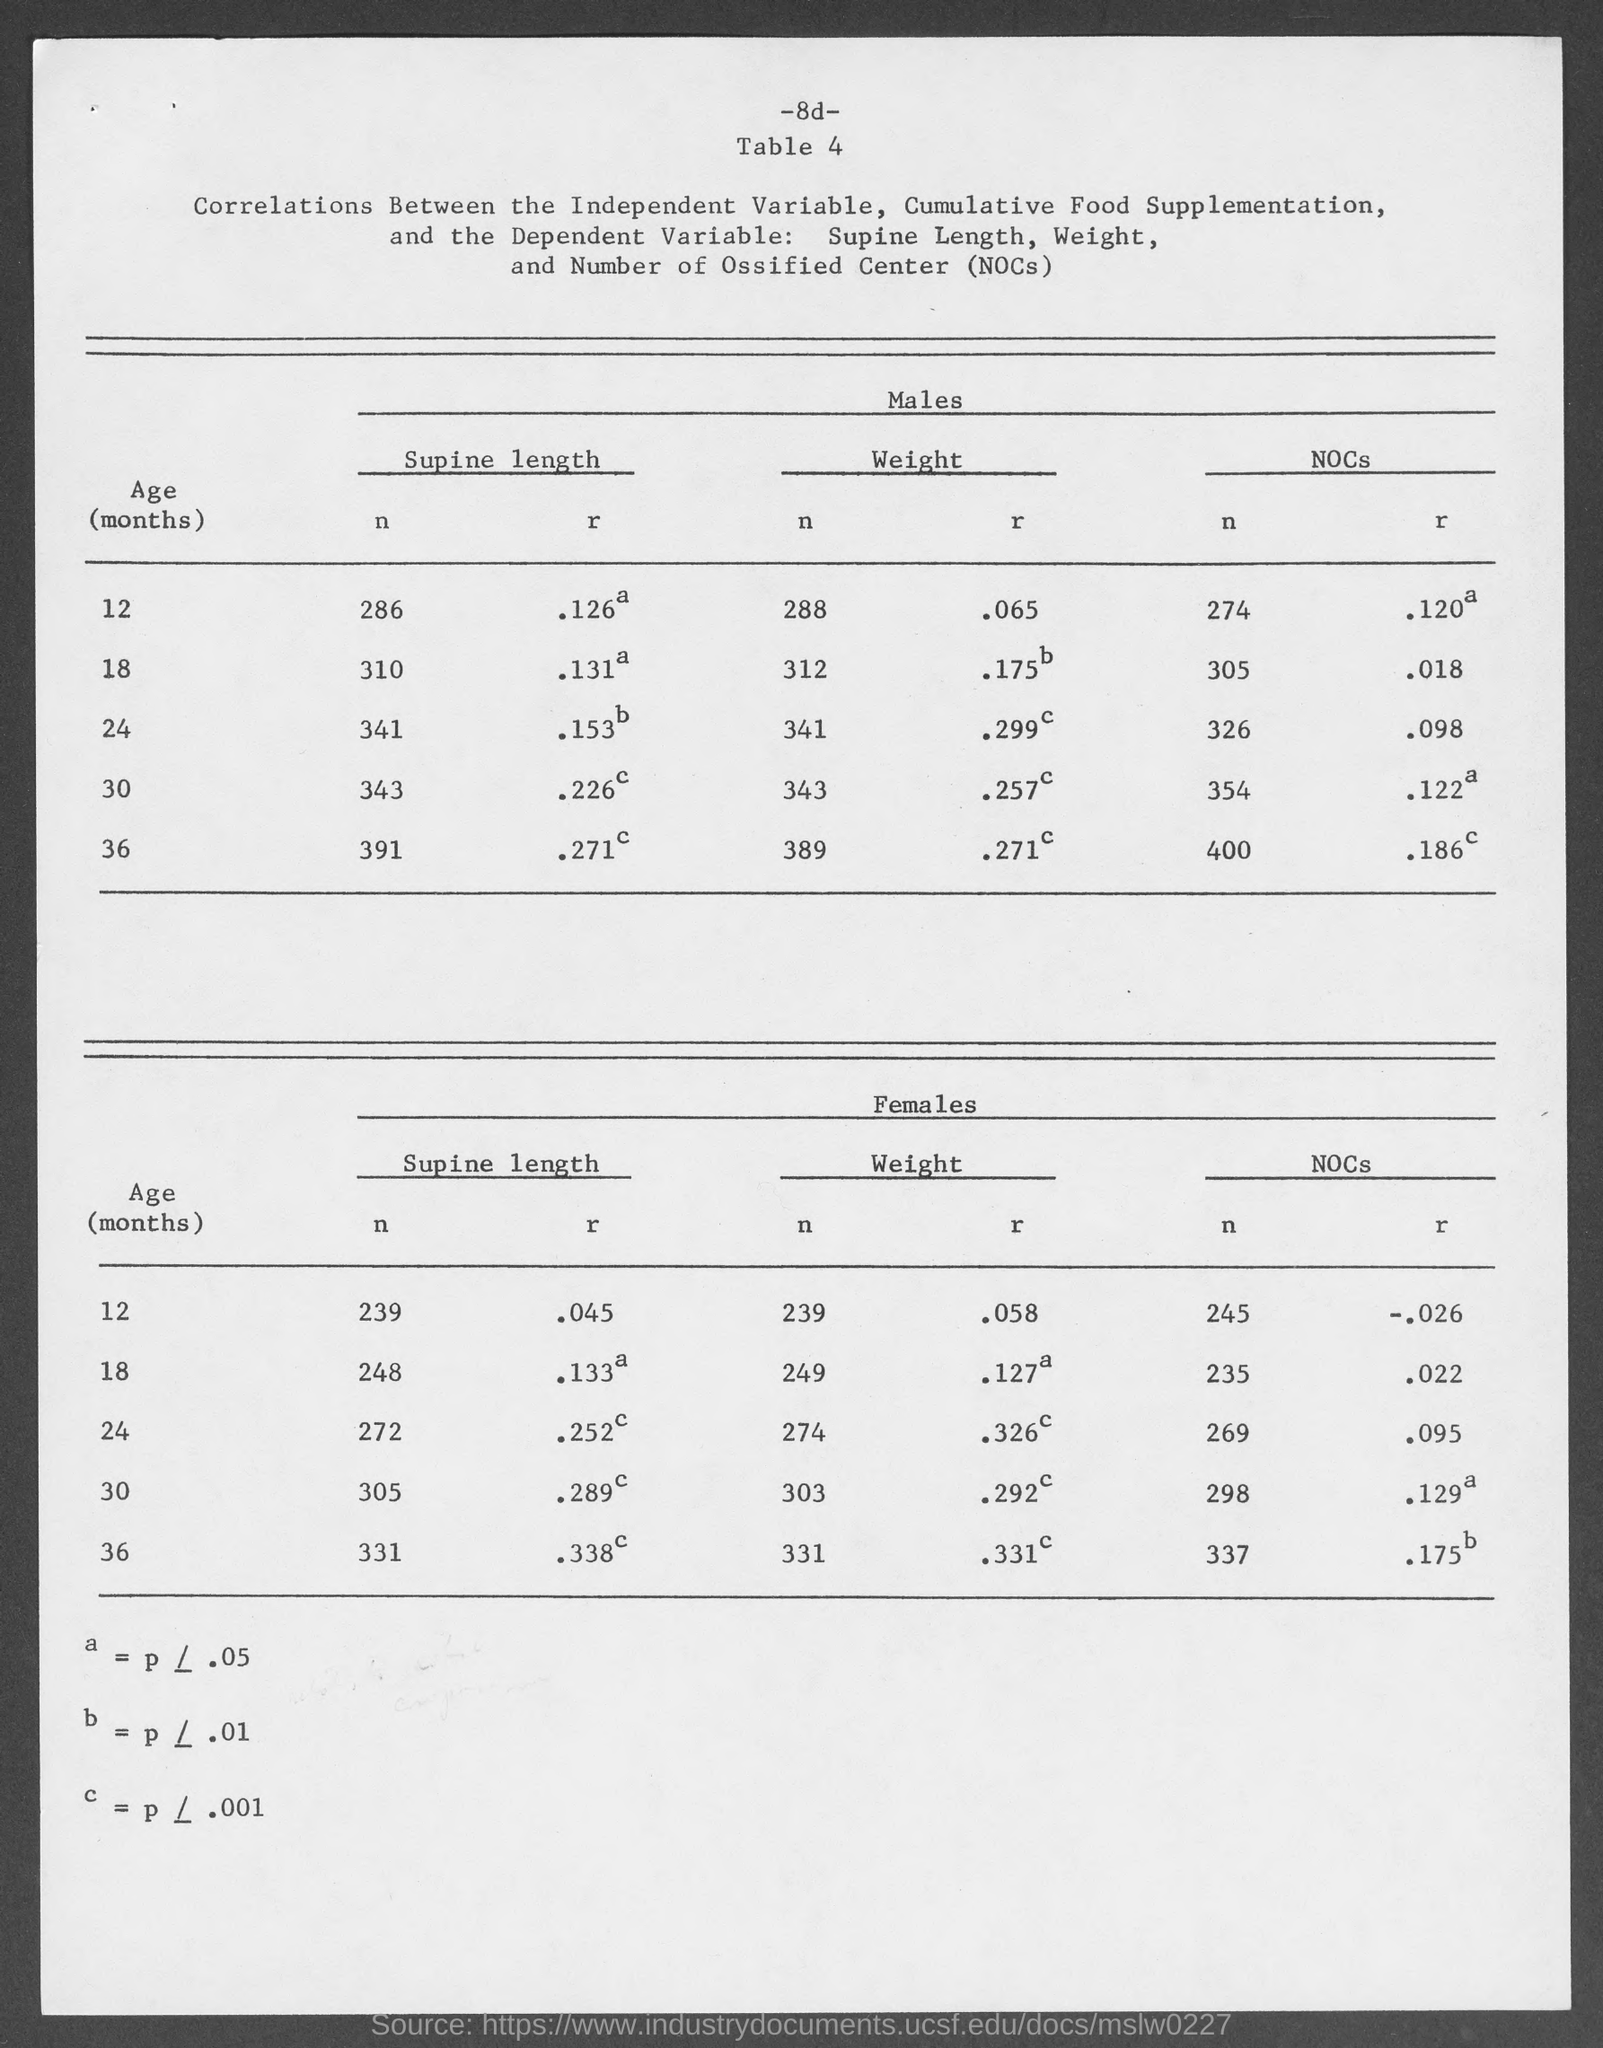What is the table no.?
Your answer should be compact. Table 4. 